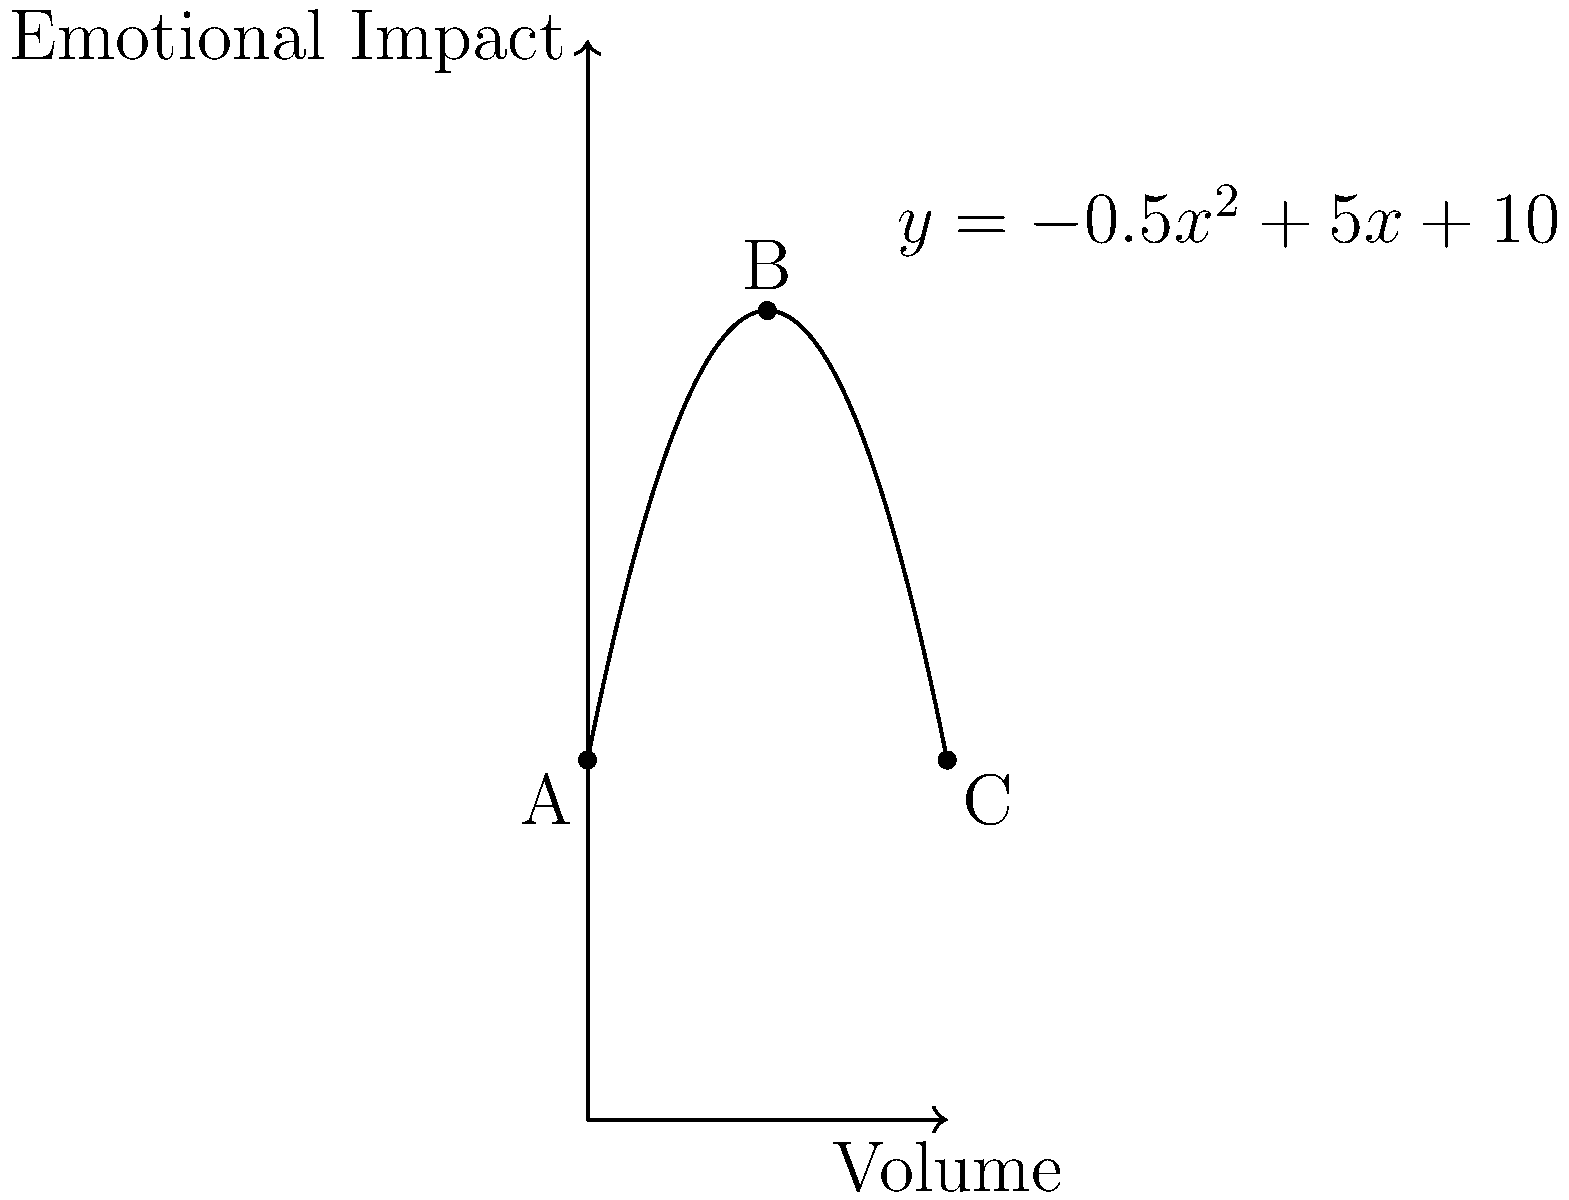As a music therapist, you're optimizing the volume level in your therapy room to maximize emotional impact. The relationship between volume (x) and emotional impact (y) is modeled by the function $y = -0.5x^2 + 5x + 10$, where x represents the volume level from 0 to 10. What volume level should you set to achieve the maximum emotional impact, and what is this maximum impact? To find the maximum emotional impact and the corresponding volume level, we need to follow these steps:

1) The function $y = -0.5x^2 + 5x + 10$ is a parabola that opens downward (because the coefficient of $x^2$ is negative).

2) The maximum point of a parabola occurs at the vertex. For a quadratic function in the form $y = ax^2 + bx + c$, the x-coordinate of the vertex is given by $x = -\frac{b}{2a}$.

3) In our case, $a = -0.5$, $b = 5$, and $c = 10$. Let's calculate the x-coordinate of the vertex:

   $x = -\frac{b}{2a} = -\frac{5}{2(-0.5)} = -\frac{5}{-1} = 5$

4) This means the optimal volume level is 5.

5) To find the maximum emotional impact, we need to calculate y when x = 5:

   $y = -0.5(5)^2 + 5(5) + 10$
   $= -0.5(25) + 25 + 10$
   $= -12.5 + 25 + 10$
   $= 22.5$

Therefore, the maximum emotional impact is 22.5.
Answer: Volume level: 5, Maximum impact: 22.5 